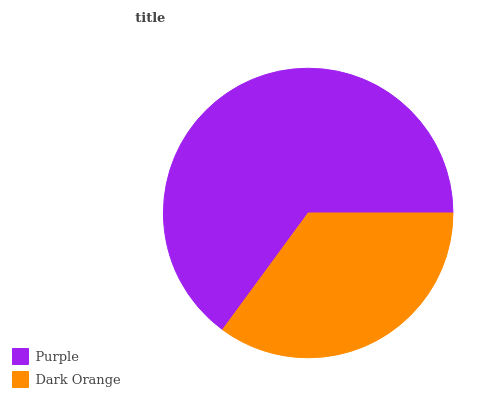Is Dark Orange the minimum?
Answer yes or no. Yes. Is Purple the maximum?
Answer yes or no. Yes. Is Dark Orange the maximum?
Answer yes or no. No. Is Purple greater than Dark Orange?
Answer yes or no. Yes. Is Dark Orange less than Purple?
Answer yes or no. Yes. Is Dark Orange greater than Purple?
Answer yes or no. No. Is Purple less than Dark Orange?
Answer yes or no. No. Is Purple the high median?
Answer yes or no. Yes. Is Dark Orange the low median?
Answer yes or no. Yes. Is Dark Orange the high median?
Answer yes or no. No. Is Purple the low median?
Answer yes or no. No. 